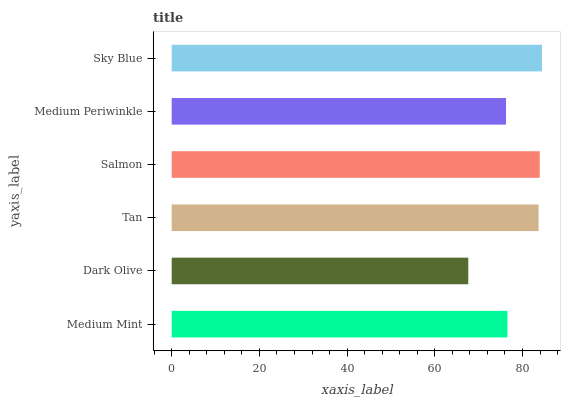Is Dark Olive the minimum?
Answer yes or no. Yes. Is Sky Blue the maximum?
Answer yes or no. Yes. Is Tan the minimum?
Answer yes or no. No. Is Tan the maximum?
Answer yes or no. No. Is Tan greater than Dark Olive?
Answer yes or no. Yes. Is Dark Olive less than Tan?
Answer yes or no. Yes. Is Dark Olive greater than Tan?
Answer yes or no. No. Is Tan less than Dark Olive?
Answer yes or no. No. Is Tan the high median?
Answer yes or no. Yes. Is Medium Mint the low median?
Answer yes or no. Yes. Is Dark Olive the high median?
Answer yes or no. No. Is Salmon the low median?
Answer yes or no. No. 